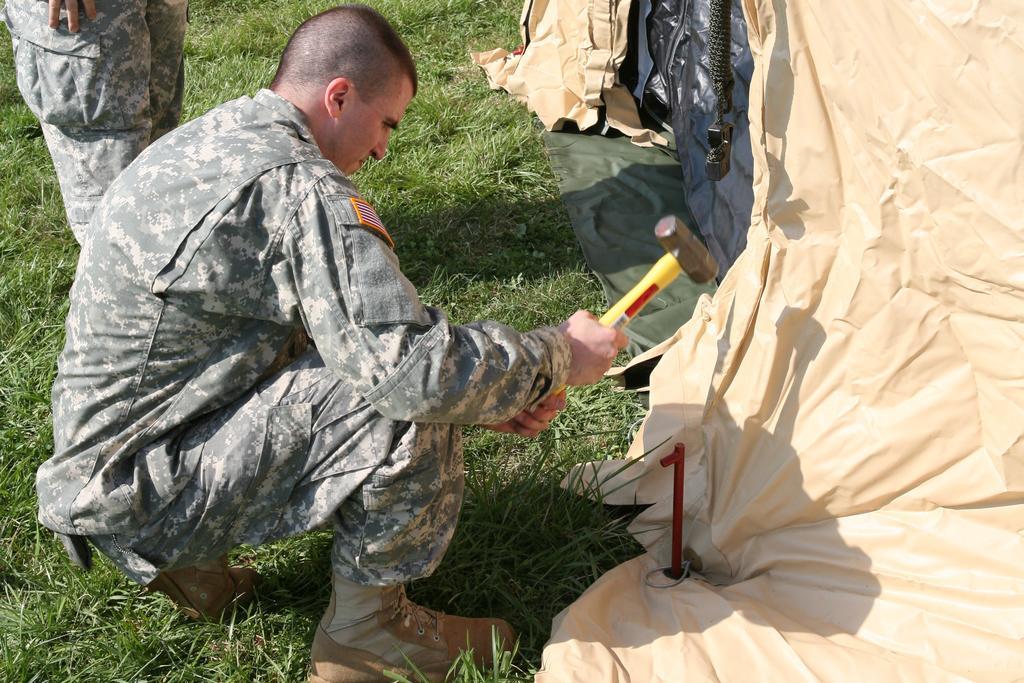Could you give a brief overview of what you see in this image? In this picture we can see a person is in squat position and holding a hammer. Behind the person another person is standing. On the right side of the people there is a tent and some objects. 